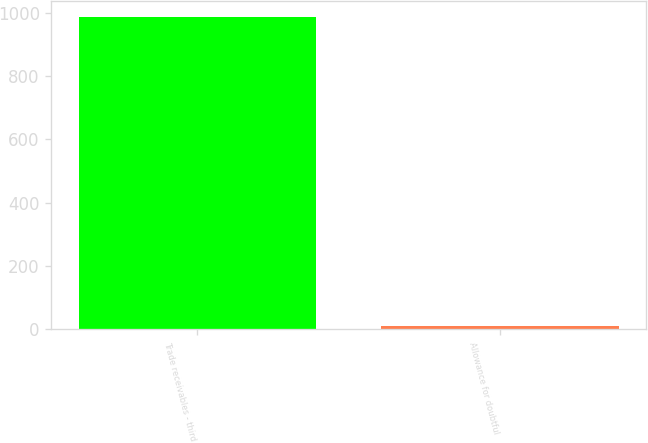<chart> <loc_0><loc_0><loc_500><loc_500><bar_chart><fcel>Trade receivables - third<fcel>Allowance for doubtful<nl><fcel>986<fcel>9<nl></chart> 